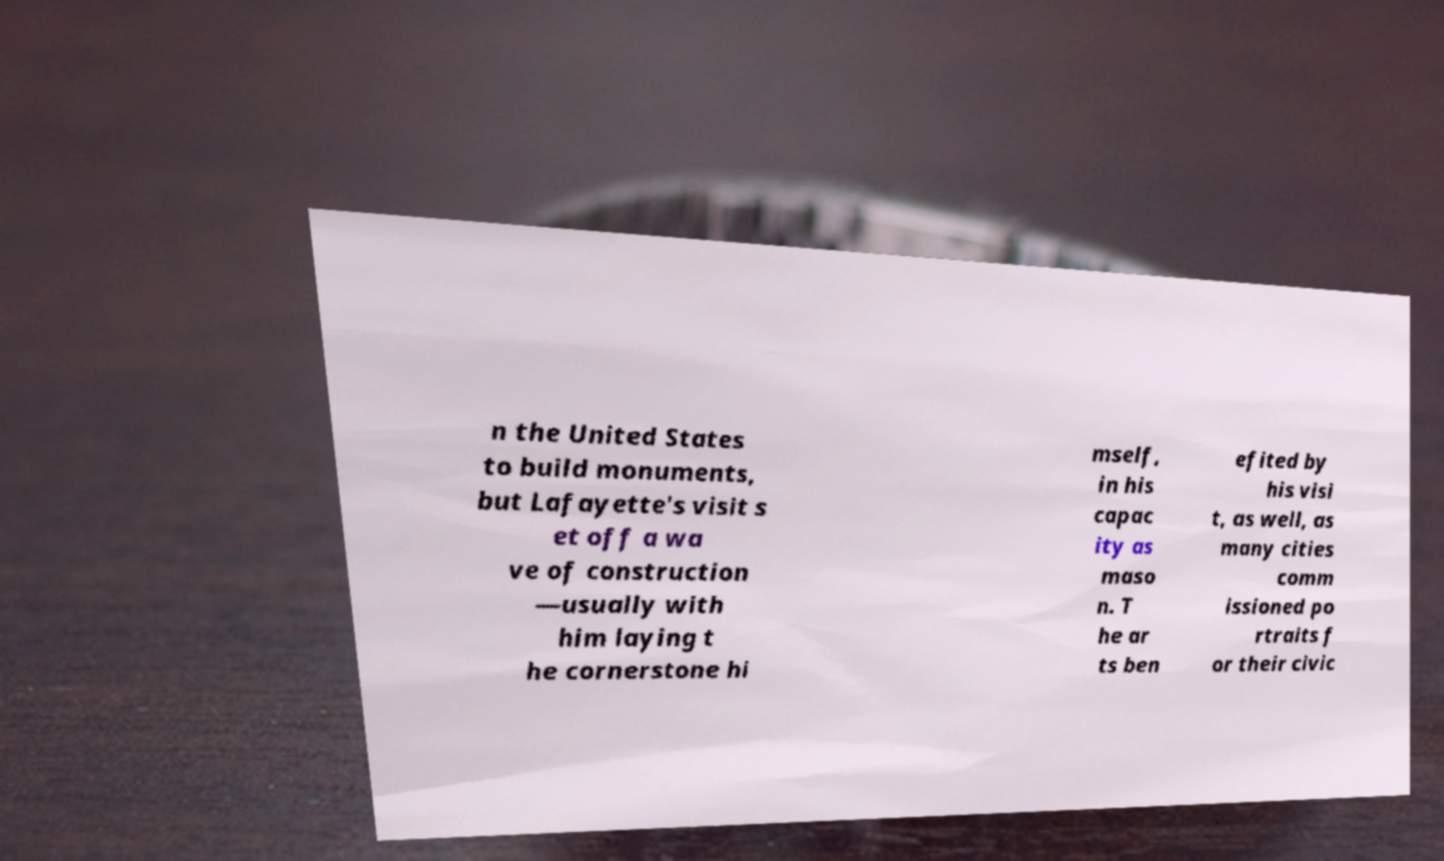There's text embedded in this image that I need extracted. Can you transcribe it verbatim? n the United States to build monuments, but Lafayette's visit s et off a wa ve of construction —usually with him laying t he cornerstone hi mself, in his capac ity as maso n. T he ar ts ben efited by his visi t, as well, as many cities comm issioned po rtraits f or their civic 